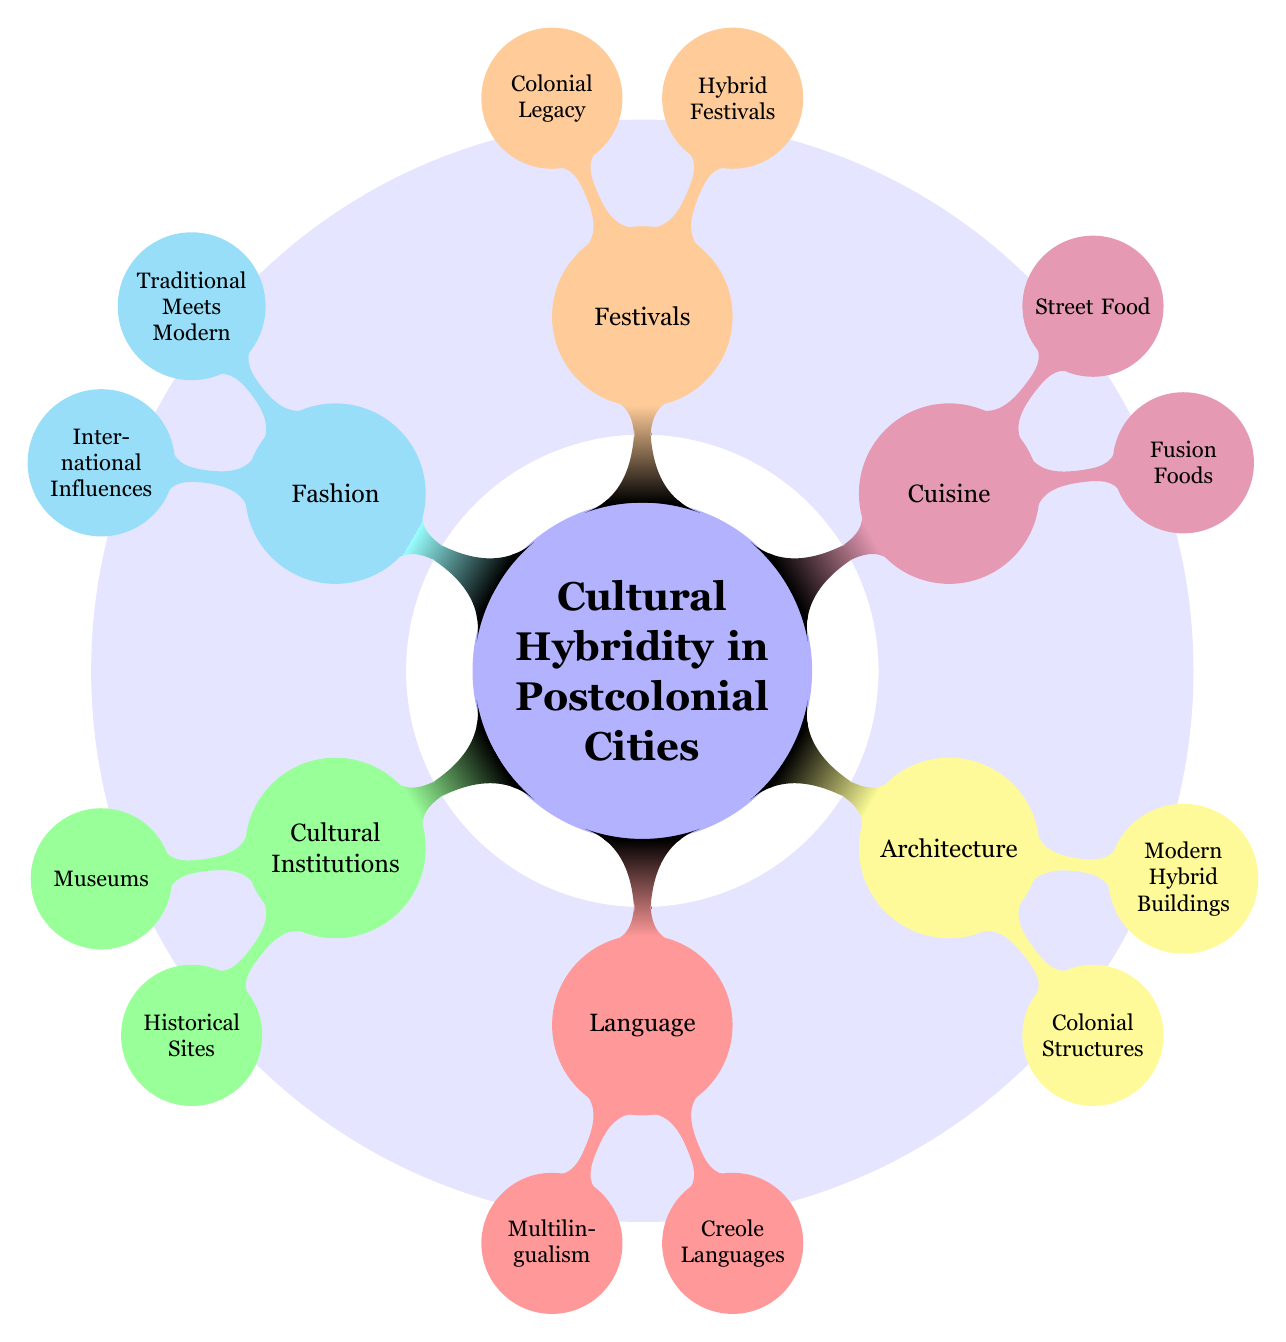What is an example of a museum in a postcolonial city? The diagram highlights "Apartheid Museum in Johannesburg" under the "Museums" node, which is a specific example of a cultural institution related to cultural hybridity.
Answer: Apartheid Museum in Johannesburg Which aspect of cultural hybridity addresses food? In the diagram, "Cuisine" is specifically listed as an aspect of cultural hybridity, which includes various food-related examples.
Answer: Cuisine How many main categories are there in the diagram about cultural hybridity? The diagram shows six main categories stemming from the central theme of "Cultural Hybridity in Postcolonial Cities." These categories are Cultural Institutions, Language, Architecture, Cuisine, Festivals, and Fashion.
Answer: 6 What is an example of a street food mentioned in the context of cultural hybridity? Under the "Cuisine" category, the diagram provides "Tacos al Pastor in Mexico City" as a specific example of street food that reflects cultural hybridity.
Answer: Tacos al Pastor in Mexico City Which category includes the example of "Kente cloth streetwear"? The example "Kente cloth streetwear in Accra" is listed under the "Fashion" category within the diagram, showing the blend of traditional and modern influences.
Answer: Fashion What is highlighted as a type of language used in postcolonial cities? The diagram specifies "Multilingualism" and "Creole Languages" under the "Language" aspect, representing forms of communication influenced by cultural hybridity.
Answer: Multilingualism and Creole Languages What is the relationship between 'Hybrid Festivals' and postcolonial cultural identity? "Hybrid Festivals," represented in the diagram, signifies events that blend traditional and contemporary cultural elements, showcasing how postcolonial identities evolve over time.
Answer: Hybrid Festivals Which two architectural styles are mentioned in the context of postcolonial cities? The two styles listed in the "Architecture" category are "Colonial Structures" and "Modern Hybrid Buildings," reflecting the architectural influences resulting from cultural hybridity.
Answer: Colonial Structures and Modern Hybrid Buildings 